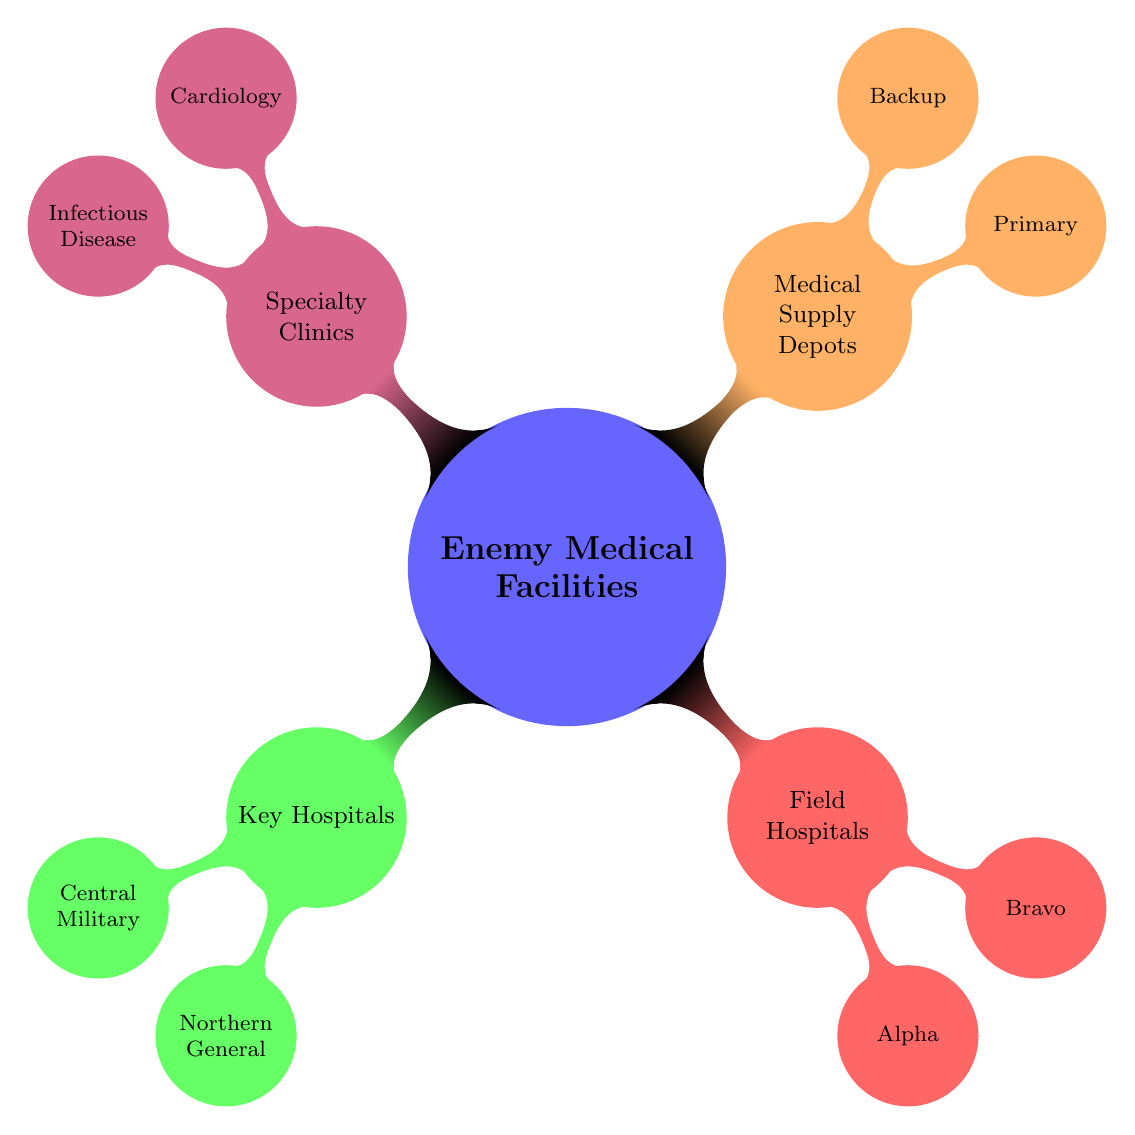What are the two categories of enemy medical facilities? The diagram shows four main categories of enemy medical facilities: Key Hospitals, Field Hospitals, Medical Supply Depots, and Specialty Clinics.
Answer: Key Hospitals and Field Hospitals How many specialty clinics are represented in the diagram? The diagram lists two specialty clinics: Cardiology Clinic and Infectious Disease Clinic. By counting these nodes, we determine the total number of specialty clinics.
Answer: 2 What is the location of the Northern General Hospital? According to the diagram, the Northern General Hospital is located in the Northern Suburbs. This information can be directly found under the Key Hospitals section.
Answer: Northern Suburbs Which field hospital is located near the North Border? The diagram indicates that Temporary Field Hospital Alpha is located near the North Border, making it identifiable from the Field Hospitals section.
Answer: Temporary Field Hospital Alpha What capabilities does the Central Military Hospital have? The Central Military Hospital is noted for its capabilities in trauma care, advanced surgery, and specialized treatment. This information can be found under its respective node in the Key Hospitals section.
Answer: Trauma care, advanced surgery, specialized treatment What vulnerabilities are associated with the Primary Supply Depot? The diagram indicates that the vulnerabilities of the Primary Supply Depot are security risks and single point of failure, which are listed under the Medical Supply Depots section.
Answer: Security risks, single point of failure Which specialty clinic is located in the Affluent Area? The Affluent Area is home to the Cardiology Clinic, as noted in the Specialty Clinics section of the diagram. This can be easily identified by checking the location details listed there.
Answer: Cardiology Clinic How many medical supply depots are shown in the diagram? The diagram presents two medical supply depots: Primary Supply Depot and Backup Supply Depot. By counting these nodes, we arrive at the total number of depots.
Answer: 2 